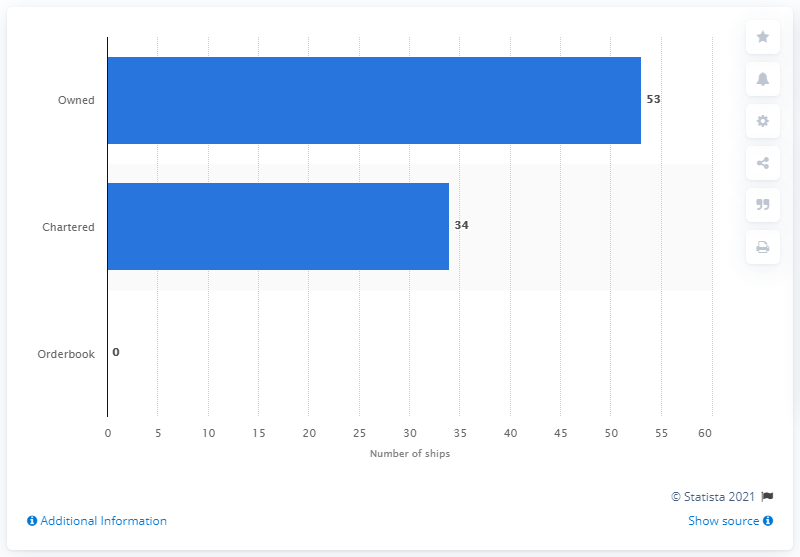Draw attention to some important aspects in this diagram. As of May 18, 2016, APL had a fleet of 53 ships. 